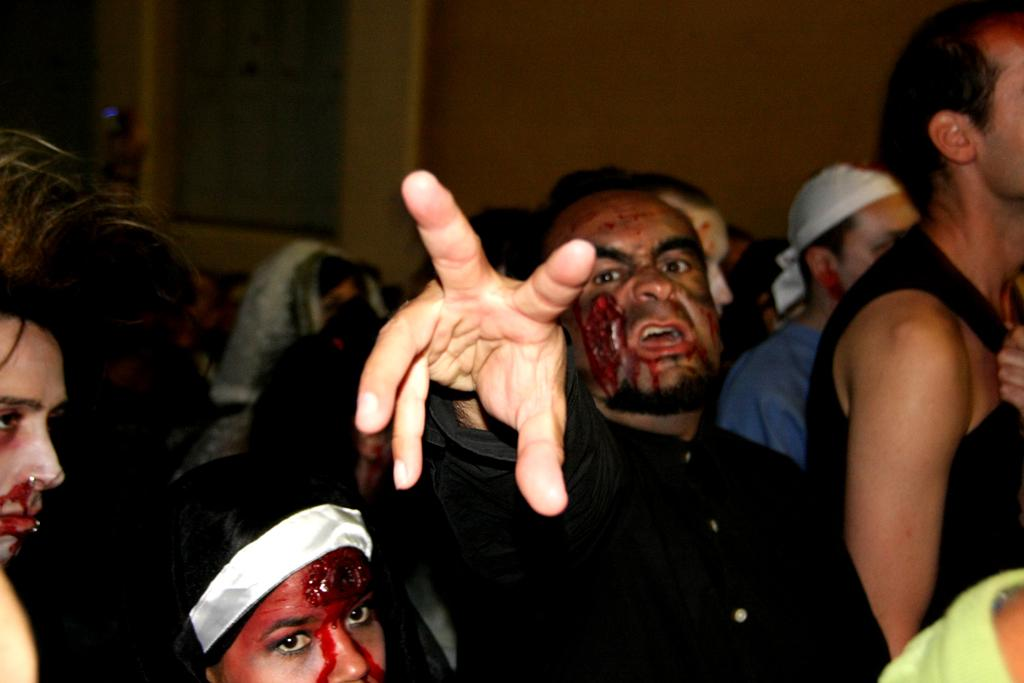Who is the main subject in the image? There is a man in the image. What is happening with the two persons in front of the man? The two persons have blood marks on them. Can you describe the scene in the background of the image? There are more persons visible in the background of the image. What type of honey is being served with the fork in the image? There is no honey or fork present in the image. What part of the body is the man using to interact with the persons in front of him? The image does not show the man using any part of his body to interact with the persons in front of him. 